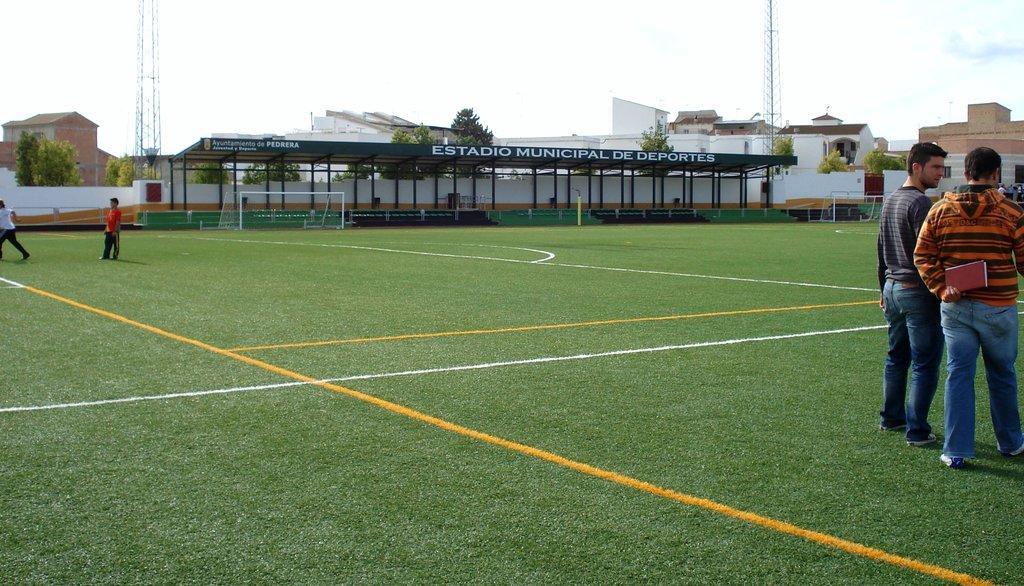Please provide a concise description of this image. In this image we can see group of persons standing on the ground. One person is holding a book in his hand. In the background, we can see a shed, group of poles, goal post, a group of trees, buildings and the sky. 